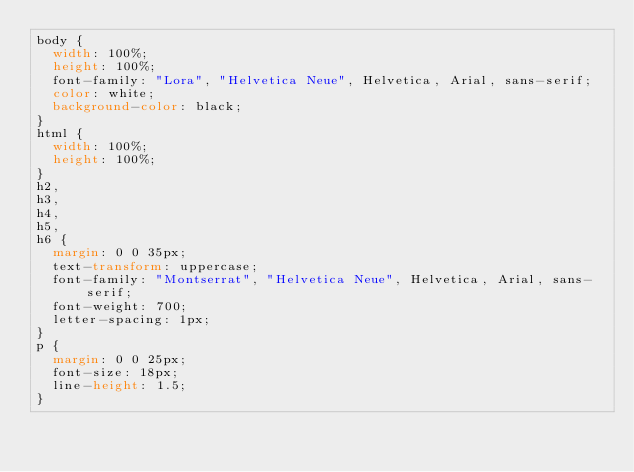<code> <loc_0><loc_0><loc_500><loc_500><_CSS_>body {
  width: 100%;
  height: 100%;
  font-family: "Lora", "Helvetica Neue", Helvetica, Arial, sans-serif;
  color: white;
  background-color: black;
}
html {
  width: 100%;
  height: 100%;
}
h2,
h3,
h4,
h5,
h6 {
  margin: 0 0 35px;
  text-transform: uppercase;
  font-family: "Montserrat", "Helvetica Neue", Helvetica, Arial, sans-serif;
  font-weight: 700;
  letter-spacing: 1px;
}
p {
  margin: 0 0 25px;
  font-size: 18px;
  line-height: 1.5;
}</code> 